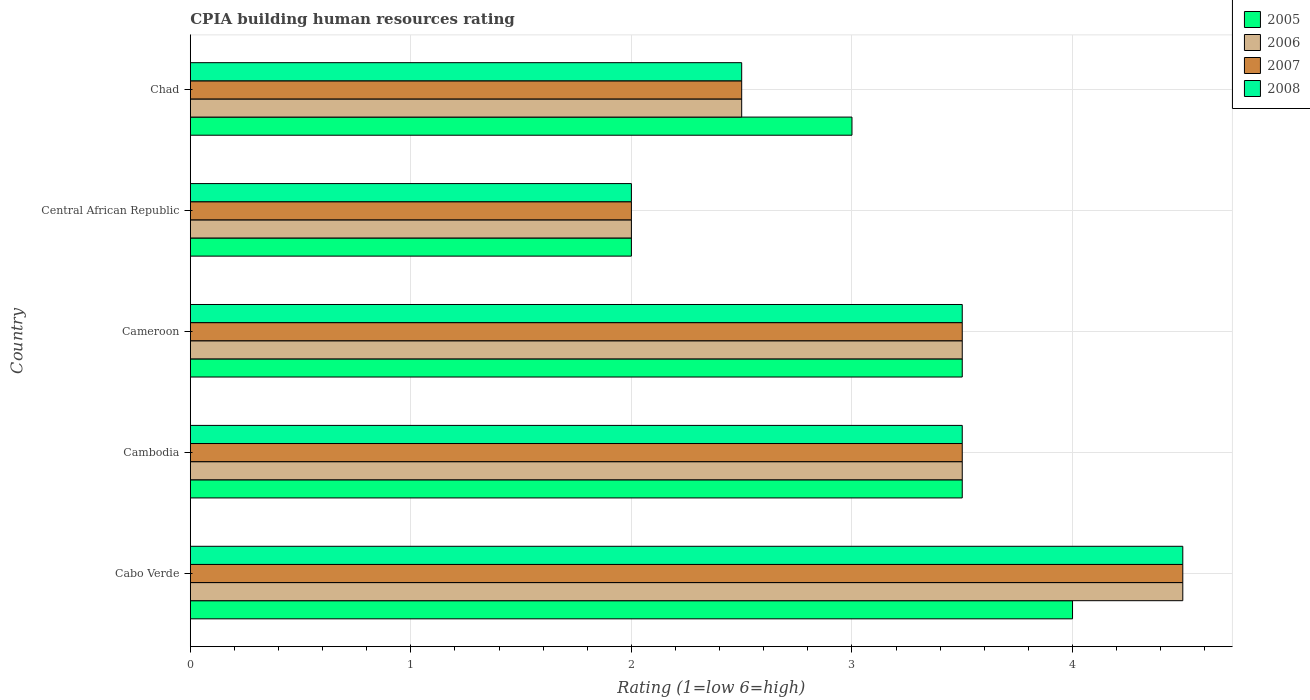How many different coloured bars are there?
Ensure brevity in your answer.  4. How many groups of bars are there?
Offer a terse response. 5. Are the number of bars per tick equal to the number of legend labels?
Provide a short and direct response. Yes. Are the number of bars on each tick of the Y-axis equal?
Make the answer very short. Yes. What is the label of the 3rd group of bars from the top?
Offer a very short reply. Cameroon. What is the CPIA rating in 2006 in Central African Republic?
Offer a terse response. 2. Across all countries, what is the maximum CPIA rating in 2008?
Provide a succinct answer. 4.5. In which country was the CPIA rating in 2007 maximum?
Ensure brevity in your answer.  Cabo Verde. In which country was the CPIA rating in 2007 minimum?
Provide a succinct answer. Central African Republic. What is the total CPIA rating in 2008 in the graph?
Offer a terse response. 16. What is the average CPIA rating in 2008 per country?
Your answer should be very brief. 3.2. Is the CPIA rating in 2006 in Cabo Verde less than that in Cambodia?
Keep it short and to the point. No. Is it the case that in every country, the sum of the CPIA rating in 2008 and CPIA rating in 2005 is greater than the sum of CPIA rating in 2007 and CPIA rating in 2006?
Your answer should be very brief. No. What does the 3rd bar from the bottom in Chad represents?
Offer a terse response. 2007. How many bars are there?
Provide a succinct answer. 20. What is the difference between two consecutive major ticks on the X-axis?
Give a very brief answer. 1. Does the graph contain any zero values?
Make the answer very short. No. Does the graph contain grids?
Offer a very short reply. Yes. Where does the legend appear in the graph?
Provide a succinct answer. Top right. How are the legend labels stacked?
Give a very brief answer. Vertical. What is the title of the graph?
Provide a succinct answer. CPIA building human resources rating. What is the label or title of the X-axis?
Your answer should be very brief. Rating (1=low 6=high). What is the label or title of the Y-axis?
Make the answer very short. Country. What is the Rating (1=low 6=high) of 2005 in Cambodia?
Ensure brevity in your answer.  3.5. What is the Rating (1=low 6=high) of 2007 in Cambodia?
Ensure brevity in your answer.  3.5. What is the Rating (1=low 6=high) of 2005 in Cameroon?
Provide a short and direct response. 3.5. What is the Rating (1=low 6=high) of 2006 in Cameroon?
Provide a short and direct response. 3.5. What is the Rating (1=low 6=high) of 2007 in Cameroon?
Your answer should be compact. 3.5. What is the Rating (1=low 6=high) in 2008 in Cameroon?
Keep it short and to the point. 3.5. What is the Rating (1=low 6=high) of 2005 in Central African Republic?
Your answer should be very brief. 2. What is the Rating (1=low 6=high) in 2007 in Central African Republic?
Ensure brevity in your answer.  2. What is the Rating (1=low 6=high) of 2005 in Chad?
Offer a very short reply. 3. What is the Rating (1=low 6=high) in 2008 in Chad?
Provide a short and direct response. 2.5. Across all countries, what is the minimum Rating (1=low 6=high) of 2005?
Offer a terse response. 2. Across all countries, what is the minimum Rating (1=low 6=high) in 2008?
Your answer should be very brief. 2. What is the total Rating (1=low 6=high) in 2006 in the graph?
Your response must be concise. 16. What is the total Rating (1=low 6=high) in 2007 in the graph?
Make the answer very short. 16. What is the difference between the Rating (1=low 6=high) of 2005 in Cabo Verde and that in Cambodia?
Offer a very short reply. 0.5. What is the difference between the Rating (1=low 6=high) of 2006 in Cabo Verde and that in Cambodia?
Your answer should be compact. 1. What is the difference between the Rating (1=low 6=high) in 2008 in Cabo Verde and that in Cambodia?
Provide a short and direct response. 1. What is the difference between the Rating (1=low 6=high) of 2007 in Cabo Verde and that in Cameroon?
Your answer should be very brief. 1. What is the difference between the Rating (1=low 6=high) of 2008 in Cabo Verde and that in Cameroon?
Make the answer very short. 1. What is the difference between the Rating (1=low 6=high) in 2007 in Cabo Verde and that in Central African Republic?
Keep it short and to the point. 2.5. What is the difference between the Rating (1=low 6=high) of 2005 in Cabo Verde and that in Chad?
Offer a very short reply. 1. What is the difference between the Rating (1=low 6=high) of 2008 in Cabo Verde and that in Chad?
Ensure brevity in your answer.  2. What is the difference between the Rating (1=low 6=high) of 2005 in Cambodia and that in Chad?
Your answer should be very brief. 0.5. What is the difference between the Rating (1=low 6=high) of 2006 in Cambodia and that in Chad?
Make the answer very short. 1. What is the difference between the Rating (1=low 6=high) of 2007 in Cambodia and that in Chad?
Your answer should be compact. 1. What is the difference between the Rating (1=low 6=high) in 2005 in Cameroon and that in Central African Republic?
Offer a terse response. 1.5. What is the difference between the Rating (1=low 6=high) in 2008 in Cameroon and that in Central African Republic?
Your answer should be very brief. 1.5. What is the difference between the Rating (1=low 6=high) of 2007 in Cameroon and that in Chad?
Make the answer very short. 1. What is the difference between the Rating (1=low 6=high) in 2005 in Central African Republic and that in Chad?
Your answer should be compact. -1. What is the difference between the Rating (1=low 6=high) of 2007 in Central African Republic and that in Chad?
Offer a very short reply. -0.5. What is the difference between the Rating (1=low 6=high) of 2008 in Central African Republic and that in Chad?
Your response must be concise. -0.5. What is the difference between the Rating (1=low 6=high) of 2005 in Cabo Verde and the Rating (1=low 6=high) of 2007 in Cambodia?
Provide a succinct answer. 0.5. What is the difference between the Rating (1=low 6=high) of 2005 in Cabo Verde and the Rating (1=low 6=high) of 2008 in Cambodia?
Provide a short and direct response. 0.5. What is the difference between the Rating (1=low 6=high) of 2006 in Cabo Verde and the Rating (1=low 6=high) of 2007 in Cambodia?
Offer a terse response. 1. What is the difference between the Rating (1=low 6=high) in 2006 in Cabo Verde and the Rating (1=low 6=high) in 2008 in Cambodia?
Your answer should be very brief. 1. What is the difference between the Rating (1=low 6=high) of 2005 in Cabo Verde and the Rating (1=low 6=high) of 2006 in Cameroon?
Offer a terse response. 0.5. What is the difference between the Rating (1=low 6=high) in 2007 in Cabo Verde and the Rating (1=low 6=high) in 2008 in Cameroon?
Keep it short and to the point. 1. What is the difference between the Rating (1=low 6=high) of 2005 in Cabo Verde and the Rating (1=low 6=high) of 2007 in Central African Republic?
Your answer should be very brief. 2. What is the difference between the Rating (1=low 6=high) in 2005 in Cabo Verde and the Rating (1=low 6=high) in 2008 in Central African Republic?
Provide a succinct answer. 2. What is the difference between the Rating (1=low 6=high) of 2006 in Cabo Verde and the Rating (1=low 6=high) of 2007 in Central African Republic?
Your response must be concise. 2.5. What is the difference between the Rating (1=low 6=high) in 2006 in Cabo Verde and the Rating (1=low 6=high) in 2008 in Central African Republic?
Your answer should be compact. 2.5. What is the difference between the Rating (1=low 6=high) in 2005 in Cabo Verde and the Rating (1=low 6=high) in 2006 in Chad?
Ensure brevity in your answer.  1.5. What is the difference between the Rating (1=low 6=high) of 2005 in Cabo Verde and the Rating (1=low 6=high) of 2007 in Chad?
Your response must be concise. 1.5. What is the difference between the Rating (1=low 6=high) of 2005 in Cabo Verde and the Rating (1=low 6=high) of 2008 in Chad?
Make the answer very short. 1.5. What is the difference between the Rating (1=low 6=high) in 2006 in Cambodia and the Rating (1=low 6=high) in 2007 in Cameroon?
Offer a terse response. 0. What is the difference between the Rating (1=low 6=high) in 2006 in Cambodia and the Rating (1=low 6=high) in 2008 in Cameroon?
Ensure brevity in your answer.  0. What is the difference between the Rating (1=low 6=high) in 2005 in Cambodia and the Rating (1=low 6=high) in 2008 in Central African Republic?
Keep it short and to the point. 1.5. What is the difference between the Rating (1=low 6=high) in 2006 in Cambodia and the Rating (1=low 6=high) in 2008 in Central African Republic?
Your response must be concise. 1.5. What is the difference between the Rating (1=low 6=high) in 2005 in Cambodia and the Rating (1=low 6=high) in 2007 in Chad?
Offer a terse response. 1. What is the difference between the Rating (1=low 6=high) in 2005 in Cambodia and the Rating (1=low 6=high) in 2008 in Chad?
Provide a short and direct response. 1. What is the difference between the Rating (1=low 6=high) in 2005 in Cameroon and the Rating (1=low 6=high) in 2006 in Central African Republic?
Your answer should be very brief. 1.5. What is the difference between the Rating (1=low 6=high) of 2005 in Cameroon and the Rating (1=low 6=high) of 2007 in Central African Republic?
Keep it short and to the point. 1.5. What is the difference between the Rating (1=low 6=high) of 2005 in Cameroon and the Rating (1=low 6=high) of 2008 in Central African Republic?
Offer a terse response. 1.5. What is the difference between the Rating (1=low 6=high) in 2006 in Cameroon and the Rating (1=low 6=high) in 2007 in Central African Republic?
Your answer should be very brief. 1.5. What is the difference between the Rating (1=low 6=high) of 2007 in Cameroon and the Rating (1=low 6=high) of 2008 in Central African Republic?
Your answer should be compact. 1.5. What is the difference between the Rating (1=low 6=high) in 2005 in Cameroon and the Rating (1=low 6=high) in 2006 in Chad?
Your response must be concise. 1. What is the difference between the Rating (1=low 6=high) of 2005 in Cameroon and the Rating (1=low 6=high) of 2007 in Chad?
Your answer should be very brief. 1. What is the difference between the Rating (1=low 6=high) in 2006 in Cameroon and the Rating (1=low 6=high) in 2007 in Chad?
Your answer should be compact. 1. What is the difference between the Rating (1=low 6=high) in 2006 in Cameroon and the Rating (1=low 6=high) in 2008 in Chad?
Offer a very short reply. 1. What is the difference between the Rating (1=low 6=high) in 2007 in Cameroon and the Rating (1=low 6=high) in 2008 in Chad?
Your answer should be compact. 1. What is the difference between the Rating (1=low 6=high) of 2005 in Central African Republic and the Rating (1=low 6=high) of 2006 in Chad?
Your answer should be very brief. -0.5. What is the difference between the Rating (1=low 6=high) of 2005 in Central African Republic and the Rating (1=low 6=high) of 2008 in Chad?
Your response must be concise. -0.5. What is the difference between the Rating (1=low 6=high) in 2006 in Central African Republic and the Rating (1=low 6=high) in 2007 in Chad?
Provide a succinct answer. -0.5. What is the average Rating (1=low 6=high) in 2005 per country?
Keep it short and to the point. 3.2. What is the average Rating (1=low 6=high) in 2006 per country?
Make the answer very short. 3.2. What is the average Rating (1=low 6=high) in 2007 per country?
Your response must be concise. 3.2. What is the average Rating (1=low 6=high) of 2008 per country?
Offer a very short reply. 3.2. What is the difference between the Rating (1=low 6=high) in 2005 and Rating (1=low 6=high) in 2006 in Cabo Verde?
Your answer should be very brief. -0.5. What is the difference between the Rating (1=low 6=high) of 2005 and Rating (1=low 6=high) of 2007 in Cabo Verde?
Your answer should be very brief. -0.5. What is the difference between the Rating (1=low 6=high) of 2006 and Rating (1=low 6=high) of 2007 in Cabo Verde?
Your answer should be very brief. 0. What is the difference between the Rating (1=low 6=high) in 2006 and Rating (1=low 6=high) in 2008 in Cabo Verde?
Offer a very short reply. 0. What is the difference between the Rating (1=low 6=high) of 2007 and Rating (1=low 6=high) of 2008 in Cabo Verde?
Your answer should be compact. 0. What is the difference between the Rating (1=low 6=high) of 2005 and Rating (1=low 6=high) of 2006 in Cambodia?
Ensure brevity in your answer.  0. What is the difference between the Rating (1=low 6=high) in 2005 and Rating (1=low 6=high) in 2007 in Cambodia?
Your answer should be very brief. 0. What is the difference between the Rating (1=low 6=high) in 2005 and Rating (1=low 6=high) in 2008 in Cambodia?
Give a very brief answer. 0. What is the difference between the Rating (1=low 6=high) in 2006 and Rating (1=low 6=high) in 2007 in Cambodia?
Your answer should be very brief. 0. What is the difference between the Rating (1=low 6=high) in 2007 and Rating (1=low 6=high) in 2008 in Cambodia?
Provide a short and direct response. 0. What is the difference between the Rating (1=low 6=high) of 2005 and Rating (1=low 6=high) of 2006 in Cameroon?
Your answer should be very brief. 0. What is the difference between the Rating (1=low 6=high) in 2005 and Rating (1=low 6=high) in 2007 in Cameroon?
Provide a succinct answer. 0. What is the difference between the Rating (1=low 6=high) of 2005 and Rating (1=low 6=high) of 2008 in Cameroon?
Your response must be concise. 0. What is the difference between the Rating (1=low 6=high) in 2006 and Rating (1=low 6=high) in 2007 in Cameroon?
Provide a short and direct response. 0. What is the difference between the Rating (1=low 6=high) in 2006 and Rating (1=low 6=high) in 2008 in Cameroon?
Provide a short and direct response. 0. What is the difference between the Rating (1=low 6=high) of 2007 and Rating (1=low 6=high) of 2008 in Cameroon?
Give a very brief answer. 0. What is the difference between the Rating (1=low 6=high) of 2005 and Rating (1=low 6=high) of 2006 in Central African Republic?
Your response must be concise. 0. What is the difference between the Rating (1=low 6=high) of 2005 and Rating (1=low 6=high) of 2008 in Central African Republic?
Your response must be concise. 0. What is the difference between the Rating (1=low 6=high) in 2006 and Rating (1=low 6=high) in 2007 in Central African Republic?
Your response must be concise. 0. What is the difference between the Rating (1=low 6=high) in 2005 and Rating (1=low 6=high) in 2007 in Chad?
Ensure brevity in your answer.  0.5. What is the difference between the Rating (1=low 6=high) in 2005 and Rating (1=low 6=high) in 2008 in Chad?
Offer a very short reply. 0.5. What is the difference between the Rating (1=low 6=high) of 2006 and Rating (1=low 6=high) of 2008 in Chad?
Your response must be concise. 0. What is the difference between the Rating (1=low 6=high) of 2007 and Rating (1=low 6=high) of 2008 in Chad?
Your answer should be very brief. 0. What is the ratio of the Rating (1=low 6=high) in 2005 in Cabo Verde to that in Cambodia?
Your answer should be very brief. 1.14. What is the ratio of the Rating (1=low 6=high) of 2007 in Cabo Verde to that in Cambodia?
Make the answer very short. 1.29. What is the ratio of the Rating (1=low 6=high) in 2008 in Cabo Verde to that in Cambodia?
Offer a very short reply. 1.29. What is the ratio of the Rating (1=low 6=high) in 2005 in Cabo Verde to that in Cameroon?
Ensure brevity in your answer.  1.14. What is the ratio of the Rating (1=low 6=high) in 2006 in Cabo Verde to that in Cameroon?
Give a very brief answer. 1.29. What is the ratio of the Rating (1=low 6=high) in 2008 in Cabo Verde to that in Cameroon?
Your response must be concise. 1.29. What is the ratio of the Rating (1=low 6=high) in 2005 in Cabo Verde to that in Central African Republic?
Your answer should be compact. 2. What is the ratio of the Rating (1=low 6=high) in 2006 in Cabo Verde to that in Central African Republic?
Keep it short and to the point. 2.25. What is the ratio of the Rating (1=low 6=high) of 2007 in Cabo Verde to that in Central African Republic?
Your response must be concise. 2.25. What is the ratio of the Rating (1=low 6=high) in 2008 in Cabo Verde to that in Central African Republic?
Provide a succinct answer. 2.25. What is the ratio of the Rating (1=low 6=high) in 2007 in Cabo Verde to that in Chad?
Give a very brief answer. 1.8. What is the ratio of the Rating (1=low 6=high) of 2005 in Cambodia to that in Cameroon?
Make the answer very short. 1. What is the ratio of the Rating (1=low 6=high) of 2007 in Cambodia to that in Cameroon?
Ensure brevity in your answer.  1. What is the ratio of the Rating (1=low 6=high) in 2008 in Cambodia to that in Cameroon?
Provide a succinct answer. 1. What is the ratio of the Rating (1=low 6=high) of 2006 in Cambodia to that in Central African Republic?
Your answer should be very brief. 1.75. What is the ratio of the Rating (1=low 6=high) of 2008 in Cambodia to that in Chad?
Keep it short and to the point. 1.4. What is the ratio of the Rating (1=low 6=high) in 2007 in Cameroon to that in Central African Republic?
Your answer should be compact. 1.75. What is the ratio of the Rating (1=low 6=high) in 2008 in Cameroon to that in Central African Republic?
Your answer should be compact. 1.75. What is the ratio of the Rating (1=low 6=high) in 2005 in Cameroon to that in Chad?
Keep it short and to the point. 1.17. What is the ratio of the Rating (1=low 6=high) in 2007 in Cameroon to that in Chad?
Your response must be concise. 1.4. What is the ratio of the Rating (1=low 6=high) of 2006 in Central African Republic to that in Chad?
Your answer should be very brief. 0.8. What is the ratio of the Rating (1=low 6=high) in 2007 in Central African Republic to that in Chad?
Provide a succinct answer. 0.8. What is the difference between the highest and the second highest Rating (1=low 6=high) in 2007?
Your answer should be compact. 1. What is the difference between the highest and the second highest Rating (1=low 6=high) of 2008?
Your answer should be very brief. 1. What is the difference between the highest and the lowest Rating (1=low 6=high) of 2005?
Provide a short and direct response. 2. What is the difference between the highest and the lowest Rating (1=low 6=high) of 2007?
Your answer should be compact. 2.5. 